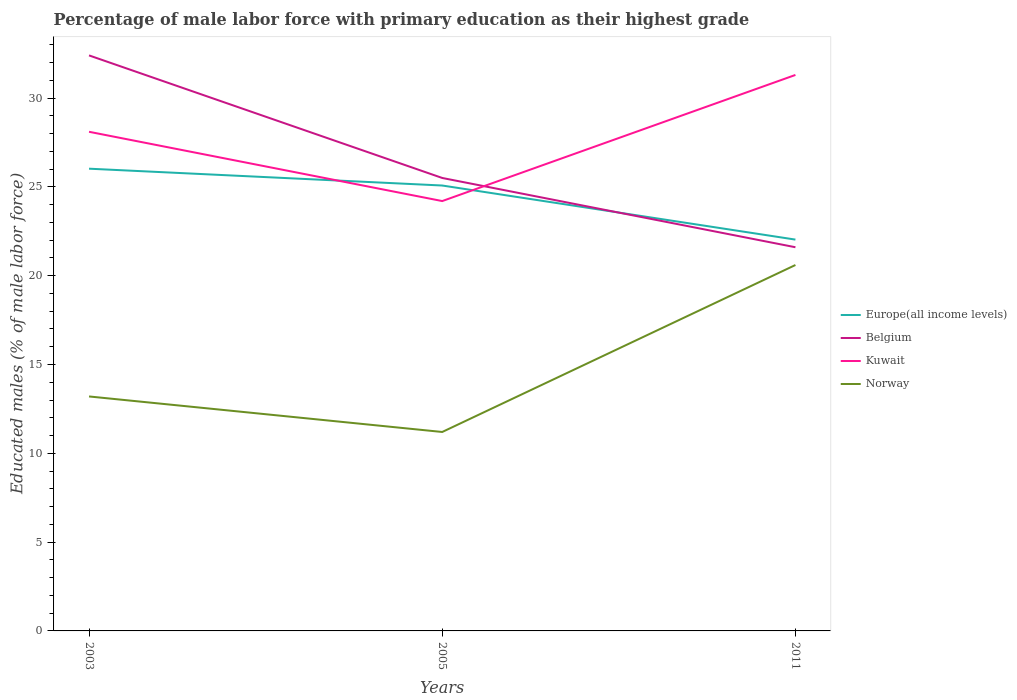How many different coloured lines are there?
Provide a short and direct response. 4. Across all years, what is the maximum percentage of male labor force with primary education in Kuwait?
Keep it short and to the point. 24.2. In which year was the percentage of male labor force with primary education in Belgium maximum?
Offer a terse response. 2011. What is the total percentage of male labor force with primary education in Europe(all income levels) in the graph?
Make the answer very short. 3.04. What is the difference between the highest and the second highest percentage of male labor force with primary education in Norway?
Offer a very short reply. 9.4. What is the difference between the highest and the lowest percentage of male labor force with primary education in Kuwait?
Offer a terse response. 2. How many lines are there?
Offer a terse response. 4. How many years are there in the graph?
Your answer should be very brief. 3. Where does the legend appear in the graph?
Give a very brief answer. Center right. How are the legend labels stacked?
Offer a very short reply. Vertical. What is the title of the graph?
Provide a short and direct response. Percentage of male labor force with primary education as their highest grade. Does "Iraq" appear as one of the legend labels in the graph?
Your answer should be compact. No. What is the label or title of the Y-axis?
Make the answer very short. Educated males (% of male labor force). What is the Educated males (% of male labor force) in Europe(all income levels) in 2003?
Provide a succinct answer. 26.02. What is the Educated males (% of male labor force) in Belgium in 2003?
Ensure brevity in your answer.  32.4. What is the Educated males (% of male labor force) in Kuwait in 2003?
Offer a very short reply. 28.1. What is the Educated males (% of male labor force) in Norway in 2003?
Offer a very short reply. 13.2. What is the Educated males (% of male labor force) of Europe(all income levels) in 2005?
Provide a succinct answer. 25.07. What is the Educated males (% of male labor force) in Kuwait in 2005?
Provide a short and direct response. 24.2. What is the Educated males (% of male labor force) of Norway in 2005?
Provide a succinct answer. 11.2. What is the Educated males (% of male labor force) of Europe(all income levels) in 2011?
Offer a very short reply. 22.03. What is the Educated males (% of male labor force) in Belgium in 2011?
Give a very brief answer. 21.6. What is the Educated males (% of male labor force) in Kuwait in 2011?
Offer a very short reply. 31.3. What is the Educated males (% of male labor force) in Norway in 2011?
Make the answer very short. 20.6. Across all years, what is the maximum Educated males (% of male labor force) in Europe(all income levels)?
Provide a succinct answer. 26.02. Across all years, what is the maximum Educated males (% of male labor force) in Belgium?
Your answer should be compact. 32.4. Across all years, what is the maximum Educated males (% of male labor force) in Kuwait?
Provide a short and direct response. 31.3. Across all years, what is the maximum Educated males (% of male labor force) in Norway?
Your answer should be compact. 20.6. Across all years, what is the minimum Educated males (% of male labor force) of Europe(all income levels)?
Keep it short and to the point. 22.03. Across all years, what is the minimum Educated males (% of male labor force) in Belgium?
Offer a terse response. 21.6. Across all years, what is the minimum Educated males (% of male labor force) in Kuwait?
Provide a short and direct response. 24.2. Across all years, what is the minimum Educated males (% of male labor force) in Norway?
Keep it short and to the point. 11.2. What is the total Educated males (% of male labor force) in Europe(all income levels) in the graph?
Your answer should be compact. 73.13. What is the total Educated males (% of male labor force) of Belgium in the graph?
Make the answer very short. 79.5. What is the total Educated males (% of male labor force) of Kuwait in the graph?
Your response must be concise. 83.6. What is the difference between the Educated males (% of male labor force) in Europe(all income levels) in 2003 and that in 2005?
Ensure brevity in your answer.  0.95. What is the difference between the Educated males (% of male labor force) in Europe(all income levels) in 2003 and that in 2011?
Make the answer very short. 3.99. What is the difference between the Educated males (% of male labor force) in Belgium in 2003 and that in 2011?
Your answer should be compact. 10.8. What is the difference between the Educated males (% of male labor force) in Kuwait in 2003 and that in 2011?
Give a very brief answer. -3.2. What is the difference between the Educated males (% of male labor force) in Norway in 2003 and that in 2011?
Keep it short and to the point. -7.4. What is the difference between the Educated males (% of male labor force) of Europe(all income levels) in 2005 and that in 2011?
Your answer should be very brief. 3.04. What is the difference between the Educated males (% of male labor force) in Kuwait in 2005 and that in 2011?
Your response must be concise. -7.1. What is the difference between the Educated males (% of male labor force) of Europe(all income levels) in 2003 and the Educated males (% of male labor force) of Belgium in 2005?
Your response must be concise. 0.52. What is the difference between the Educated males (% of male labor force) of Europe(all income levels) in 2003 and the Educated males (% of male labor force) of Kuwait in 2005?
Your answer should be very brief. 1.82. What is the difference between the Educated males (% of male labor force) of Europe(all income levels) in 2003 and the Educated males (% of male labor force) of Norway in 2005?
Make the answer very short. 14.82. What is the difference between the Educated males (% of male labor force) of Belgium in 2003 and the Educated males (% of male labor force) of Norway in 2005?
Provide a short and direct response. 21.2. What is the difference between the Educated males (% of male labor force) of Kuwait in 2003 and the Educated males (% of male labor force) of Norway in 2005?
Offer a terse response. 16.9. What is the difference between the Educated males (% of male labor force) of Europe(all income levels) in 2003 and the Educated males (% of male labor force) of Belgium in 2011?
Provide a succinct answer. 4.42. What is the difference between the Educated males (% of male labor force) in Europe(all income levels) in 2003 and the Educated males (% of male labor force) in Kuwait in 2011?
Make the answer very short. -5.28. What is the difference between the Educated males (% of male labor force) in Europe(all income levels) in 2003 and the Educated males (% of male labor force) in Norway in 2011?
Offer a very short reply. 5.42. What is the difference between the Educated males (% of male labor force) in Belgium in 2003 and the Educated males (% of male labor force) in Kuwait in 2011?
Keep it short and to the point. 1.1. What is the difference between the Educated males (% of male labor force) in Belgium in 2003 and the Educated males (% of male labor force) in Norway in 2011?
Keep it short and to the point. 11.8. What is the difference between the Educated males (% of male labor force) in Europe(all income levels) in 2005 and the Educated males (% of male labor force) in Belgium in 2011?
Offer a terse response. 3.47. What is the difference between the Educated males (% of male labor force) in Europe(all income levels) in 2005 and the Educated males (% of male labor force) in Kuwait in 2011?
Your answer should be very brief. -6.23. What is the difference between the Educated males (% of male labor force) of Europe(all income levels) in 2005 and the Educated males (% of male labor force) of Norway in 2011?
Provide a short and direct response. 4.47. What is the difference between the Educated males (% of male labor force) in Belgium in 2005 and the Educated males (% of male labor force) in Kuwait in 2011?
Give a very brief answer. -5.8. What is the difference between the Educated males (% of male labor force) of Kuwait in 2005 and the Educated males (% of male labor force) of Norway in 2011?
Make the answer very short. 3.6. What is the average Educated males (% of male labor force) of Europe(all income levels) per year?
Your answer should be very brief. 24.38. What is the average Educated males (% of male labor force) in Belgium per year?
Ensure brevity in your answer.  26.5. What is the average Educated males (% of male labor force) of Kuwait per year?
Your answer should be very brief. 27.87. What is the average Educated males (% of male labor force) of Norway per year?
Your response must be concise. 15. In the year 2003, what is the difference between the Educated males (% of male labor force) in Europe(all income levels) and Educated males (% of male labor force) in Belgium?
Keep it short and to the point. -6.38. In the year 2003, what is the difference between the Educated males (% of male labor force) of Europe(all income levels) and Educated males (% of male labor force) of Kuwait?
Ensure brevity in your answer.  -2.08. In the year 2003, what is the difference between the Educated males (% of male labor force) in Europe(all income levels) and Educated males (% of male labor force) in Norway?
Provide a succinct answer. 12.82. In the year 2005, what is the difference between the Educated males (% of male labor force) in Europe(all income levels) and Educated males (% of male labor force) in Belgium?
Your answer should be very brief. -0.43. In the year 2005, what is the difference between the Educated males (% of male labor force) in Europe(all income levels) and Educated males (% of male labor force) in Kuwait?
Offer a very short reply. 0.87. In the year 2005, what is the difference between the Educated males (% of male labor force) in Europe(all income levels) and Educated males (% of male labor force) in Norway?
Provide a succinct answer. 13.87. In the year 2011, what is the difference between the Educated males (% of male labor force) in Europe(all income levels) and Educated males (% of male labor force) in Belgium?
Provide a short and direct response. 0.43. In the year 2011, what is the difference between the Educated males (% of male labor force) of Europe(all income levels) and Educated males (% of male labor force) of Kuwait?
Offer a terse response. -9.27. In the year 2011, what is the difference between the Educated males (% of male labor force) in Europe(all income levels) and Educated males (% of male labor force) in Norway?
Your answer should be very brief. 1.43. What is the ratio of the Educated males (% of male labor force) of Europe(all income levels) in 2003 to that in 2005?
Keep it short and to the point. 1.04. What is the ratio of the Educated males (% of male labor force) of Belgium in 2003 to that in 2005?
Offer a terse response. 1.27. What is the ratio of the Educated males (% of male labor force) of Kuwait in 2003 to that in 2005?
Your answer should be compact. 1.16. What is the ratio of the Educated males (% of male labor force) in Norway in 2003 to that in 2005?
Provide a succinct answer. 1.18. What is the ratio of the Educated males (% of male labor force) in Europe(all income levels) in 2003 to that in 2011?
Ensure brevity in your answer.  1.18. What is the ratio of the Educated males (% of male labor force) of Kuwait in 2003 to that in 2011?
Provide a short and direct response. 0.9. What is the ratio of the Educated males (% of male labor force) in Norway in 2003 to that in 2011?
Ensure brevity in your answer.  0.64. What is the ratio of the Educated males (% of male labor force) in Europe(all income levels) in 2005 to that in 2011?
Provide a short and direct response. 1.14. What is the ratio of the Educated males (% of male labor force) in Belgium in 2005 to that in 2011?
Your answer should be compact. 1.18. What is the ratio of the Educated males (% of male labor force) in Kuwait in 2005 to that in 2011?
Your answer should be very brief. 0.77. What is the ratio of the Educated males (% of male labor force) of Norway in 2005 to that in 2011?
Your answer should be compact. 0.54. What is the difference between the highest and the second highest Educated males (% of male labor force) in Europe(all income levels)?
Provide a succinct answer. 0.95. What is the difference between the highest and the second highest Educated males (% of male labor force) in Belgium?
Keep it short and to the point. 6.9. What is the difference between the highest and the second highest Educated males (% of male labor force) in Kuwait?
Give a very brief answer. 3.2. What is the difference between the highest and the second highest Educated males (% of male labor force) in Norway?
Give a very brief answer. 7.4. What is the difference between the highest and the lowest Educated males (% of male labor force) in Europe(all income levels)?
Offer a very short reply. 3.99. What is the difference between the highest and the lowest Educated males (% of male labor force) of Belgium?
Ensure brevity in your answer.  10.8. What is the difference between the highest and the lowest Educated males (% of male labor force) of Norway?
Offer a very short reply. 9.4. 